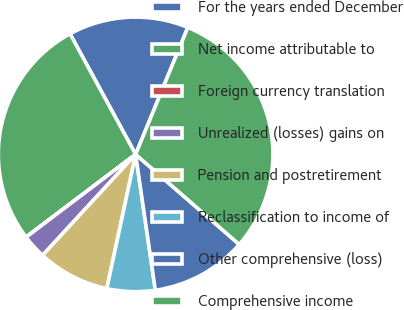Convert chart to OTSL. <chart><loc_0><loc_0><loc_500><loc_500><pie_chart><fcel>For the years ended December<fcel>Net income attributable to<fcel>Foreign currency translation<fcel>Unrealized (losses) gains on<fcel>Pension and postretirement<fcel>Reclassification to income of<fcel>Other comprehensive (loss)<fcel>Comprehensive income<nl><fcel>14.14%<fcel>27.36%<fcel>0.01%<fcel>2.84%<fcel>8.49%<fcel>5.66%<fcel>11.32%<fcel>30.18%<nl></chart> 